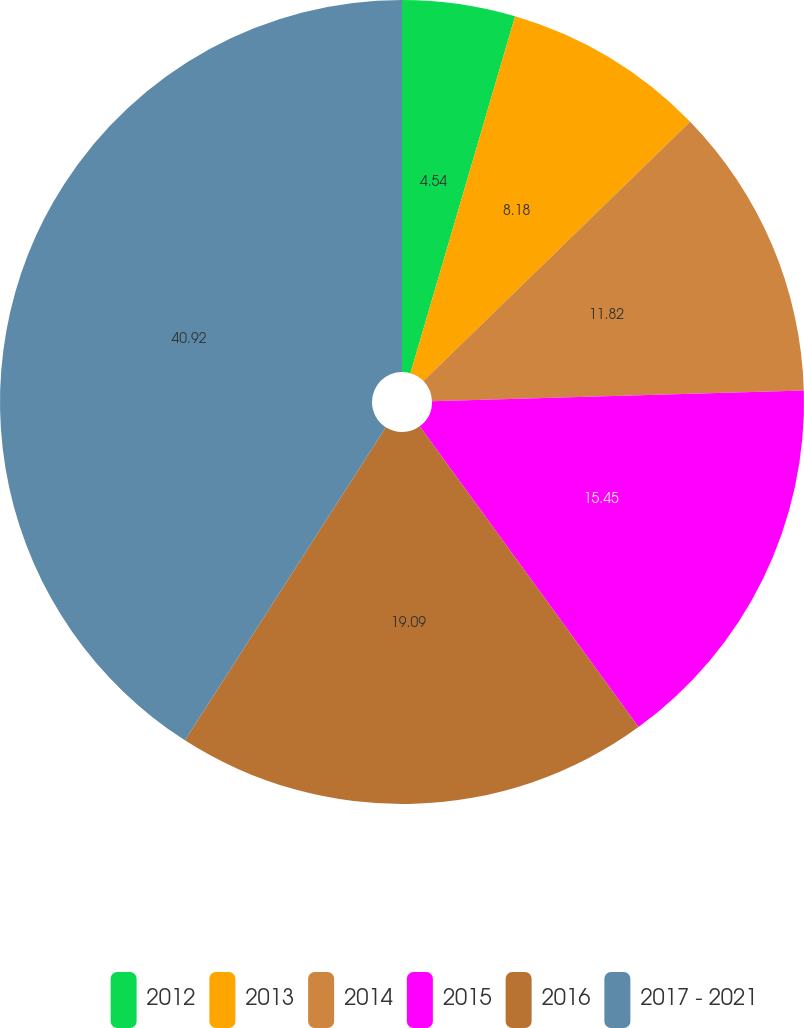Convert chart to OTSL. <chart><loc_0><loc_0><loc_500><loc_500><pie_chart><fcel>2012<fcel>2013<fcel>2014<fcel>2015<fcel>2016<fcel>2017 - 2021<nl><fcel>4.54%<fcel>8.18%<fcel>11.82%<fcel>15.45%<fcel>19.09%<fcel>40.92%<nl></chart> 